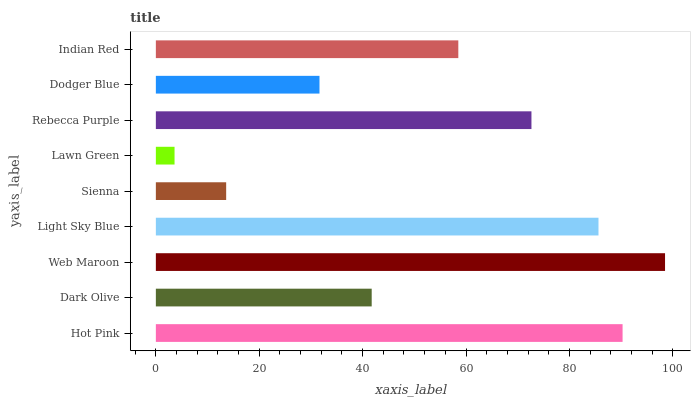Is Lawn Green the minimum?
Answer yes or no. Yes. Is Web Maroon the maximum?
Answer yes or no. Yes. Is Dark Olive the minimum?
Answer yes or no. No. Is Dark Olive the maximum?
Answer yes or no. No. Is Hot Pink greater than Dark Olive?
Answer yes or no. Yes. Is Dark Olive less than Hot Pink?
Answer yes or no. Yes. Is Dark Olive greater than Hot Pink?
Answer yes or no. No. Is Hot Pink less than Dark Olive?
Answer yes or no. No. Is Indian Red the high median?
Answer yes or no. Yes. Is Indian Red the low median?
Answer yes or no. Yes. Is Rebecca Purple the high median?
Answer yes or no. No. Is Light Sky Blue the low median?
Answer yes or no. No. 